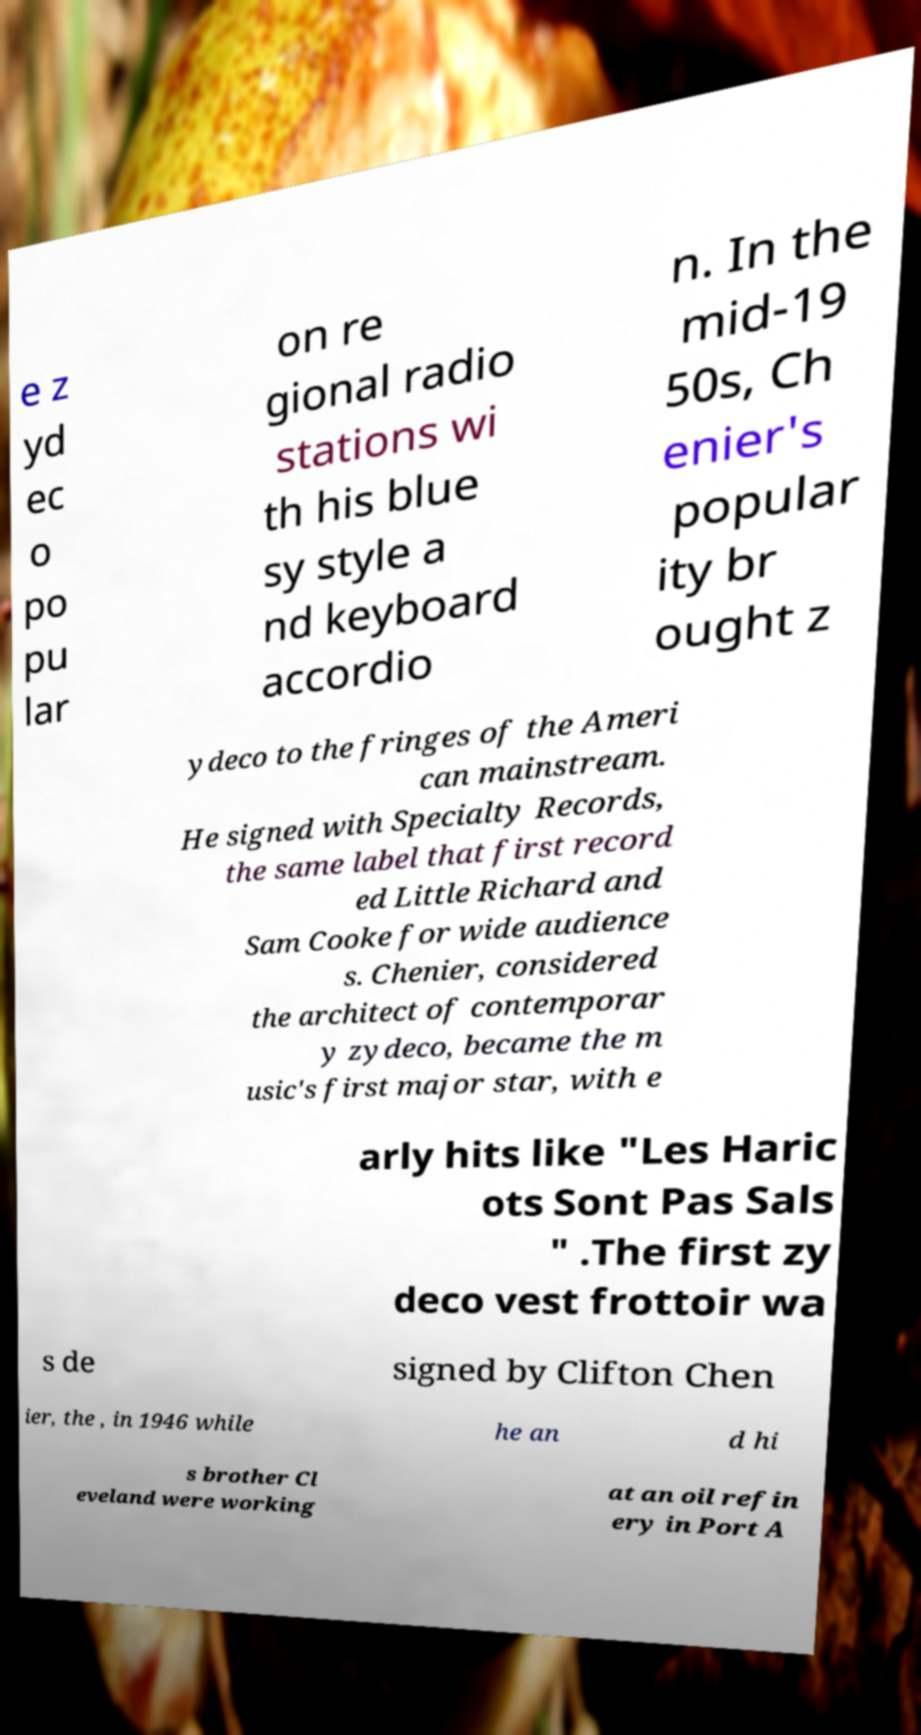Please identify and transcribe the text found in this image. e z yd ec o po pu lar on re gional radio stations wi th his blue sy style a nd keyboard accordio n. In the mid-19 50s, Ch enier's popular ity br ought z ydeco to the fringes of the Ameri can mainstream. He signed with Specialty Records, the same label that first record ed Little Richard and Sam Cooke for wide audience s. Chenier, considered the architect of contemporar y zydeco, became the m usic's first major star, with e arly hits like "Les Haric ots Sont Pas Sals " .The first zy deco vest frottoir wa s de signed by Clifton Chen ier, the , in 1946 while he an d hi s brother Cl eveland were working at an oil refin ery in Port A 